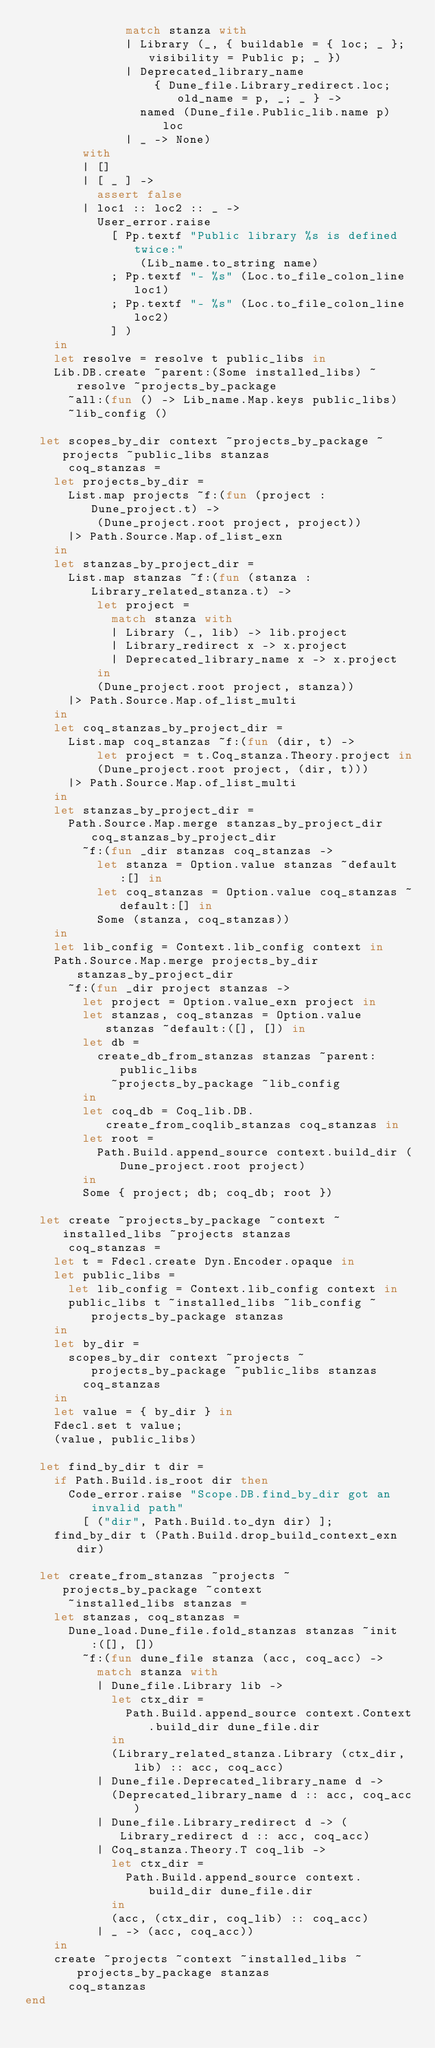Convert code to text. <code><loc_0><loc_0><loc_500><loc_500><_OCaml_>              match stanza with
              | Library (_, { buildable = { loc; _ }; visibility = Public p; _ })
              | Deprecated_library_name
                  { Dune_file.Library_redirect.loc; old_name = p, _; _ } ->
                named (Dune_file.Public_lib.name p) loc
              | _ -> None)
        with
        | []
        | [ _ ] ->
          assert false
        | loc1 :: loc2 :: _ ->
          User_error.raise
            [ Pp.textf "Public library %s is defined twice:"
                (Lib_name.to_string name)
            ; Pp.textf "- %s" (Loc.to_file_colon_line loc1)
            ; Pp.textf "- %s" (Loc.to_file_colon_line loc2)
            ] )
    in
    let resolve = resolve t public_libs in
    Lib.DB.create ~parent:(Some installed_libs) ~resolve ~projects_by_package
      ~all:(fun () -> Lib_name.Map.keys public_libs)
      ~lib_config ()

  let scopes_by_dir context ~projects_by_package ~projects ~public_libs stanzas
      coq_stanzas =
    let projects_by_dir =
      List.map projects ~f:(fun (project : Dune_project.t) ->
          (Dune_project.root project, project))
      |> Path.Source.Map.of_list_exn
    in
    let stanzas_by_project_dir =
      List.map stanzas ~f:(fun (stanza : Library_related_stanza.t) ->
          let project =
            match stanza with
            | Library (_, lib) -> lib.project
            | Library_redirect x -> x.project
            | Deprecated_library_name x -> x.project
          in
          (Dune_project.root project, stanza))
      |> Path.Source.Map.of_list_multi
    in
    let coq_stanzas_by_project_dir =
      List.map coq_stanzas ~f:(fun (dir, t) ->
          let project = t.Coq_stanza.Theory.project in
          (Dune_project.root project, (dir, t)))
      |> Path.Source.Map.of_list_multi
    in
    let stanzas_by_project_dir =
      Path.Source.Map.merge stanzas_by_project_dir coq_stanzas_by_project_dir
        ~f:(fun _dir stanzas coq_stanzas ->
          let stanza = Option.value stanzas ~default:[] in
          let coq_stanzas = Option.value coq_stanzas ~default:[] in
          Some (stanza, coq_stanzas))
    in
    let lib_config = Context.lib_config context in
    Path.Source.Map.merge projects_by_dir stanzas_by_project_dir
      ~f:(fun _dir project stanzas ->
        let project = Option.value_exn project in
        let stanzas, coq_stanzas = Option.value stanzas ~default:([], []) in
        let db =
          create_db_from_stanzas stanzas ~parent:public_libs
            ~projects_by_package ~lib_config
        in
        let coq_db = Coq_lib.DB.create_from_coqlib_stanzas coq_stanzas in
        let root =
          Path.Build.append_source context.build_dir (Dune_project.root project)
        in
        Some { project; db; coq_db; root })

  let create ~projects_by_package ~context ~installed_libs ~projects stanzas
      coq_stanzas =
    let t = Fdecl.create Dyn.Encoder.opaque in
    let public_libs =
      let lib_config = Context.lib_config context in
      public_libs t ~installed_libs ~lib_config ~projects_by_package stanzas
    in
    let by_dir =
      scopes_by_dir context ~projects ~projects_by_package ~public_libs stanzas
        coq_stanzas
    in
    let value = { by_dir } in
    Fdecl.set t value;
    (value, public_libs)

  let find_by_dir t dir =
    if Path.Build.is_root dir then
      Code_error.raise "Scope.DB.find_by_dir got an invalid path"
        [ ("dir", Path.Build.to_dyn dir) ];
    find_by_dir t (Path.Build.drop_build_context_exn dir)

  let create_from_stanzas ~projects ~projects_by_package ~context
      ~installed_libs stanzas =
    let stanzas, coq_stanzas =
      Dune_load.Dune_file.fold_stanzas stanzas ~init:([], [])
        ~f:(fun dune_file stanza (acc, coq_acc) ->
          match stanza with
          | Dune_file.Library lib ->
            let ctx_dir =
              Path.Build.append_source context.Context.build_dir dune_file.dir
            in
            (Library_related_stanza.Library (ctx_dir, lib) :: acc, coq_acc)
          | Dune_file.Deprecated_library_name d ->
            (Deprecated_library_name d :: acc, coq_acc)
          | Dune_file.Library_redirect d -> (Library_redirect d :: acc, coq_acc)
          | Coq_stanza.Theory.T coq_lib ->
            let ctx_dir =
              Path.Build.append_source context.build_dir dune_file.dir
            in
            (acc, (ctx_dir, coq_lib) :: coq_acc)
          | _ -> (acc, coq_acc))
    in
    create ~projects ~context ~installed_libs ~projects_by_package stanzas
      coq_stanzas
end
</code> 